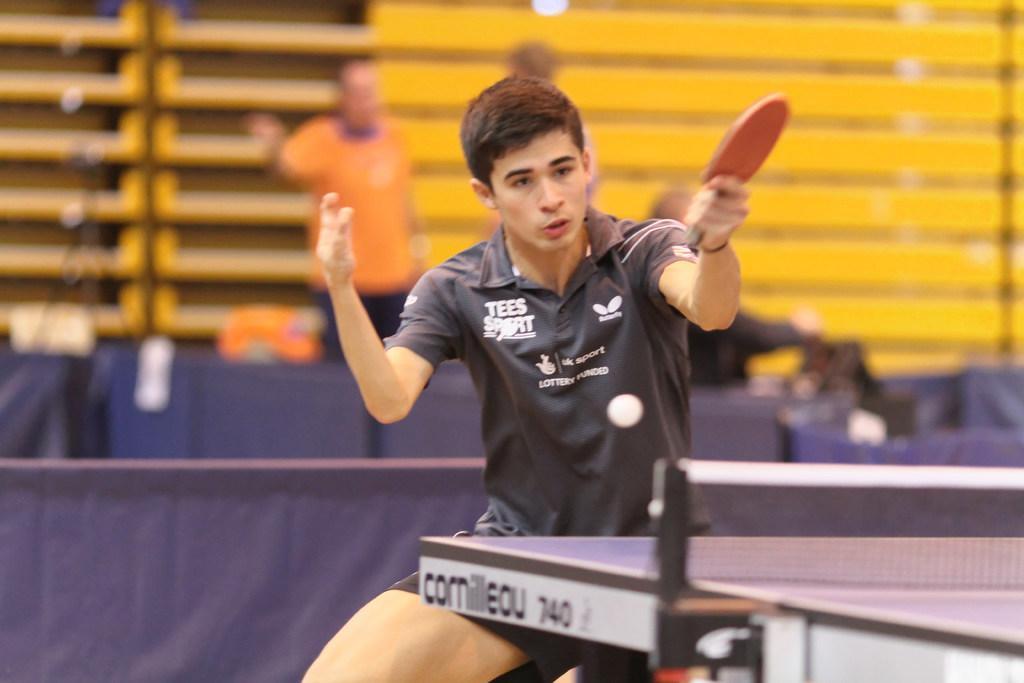How would you summarize this image in a sentence or two? A man with black t-shirt is running and holding a bat in his hand. In front of him there is a table tennis board. In the background there is a man with orange t-shirt standing and there is a blue color poster. 